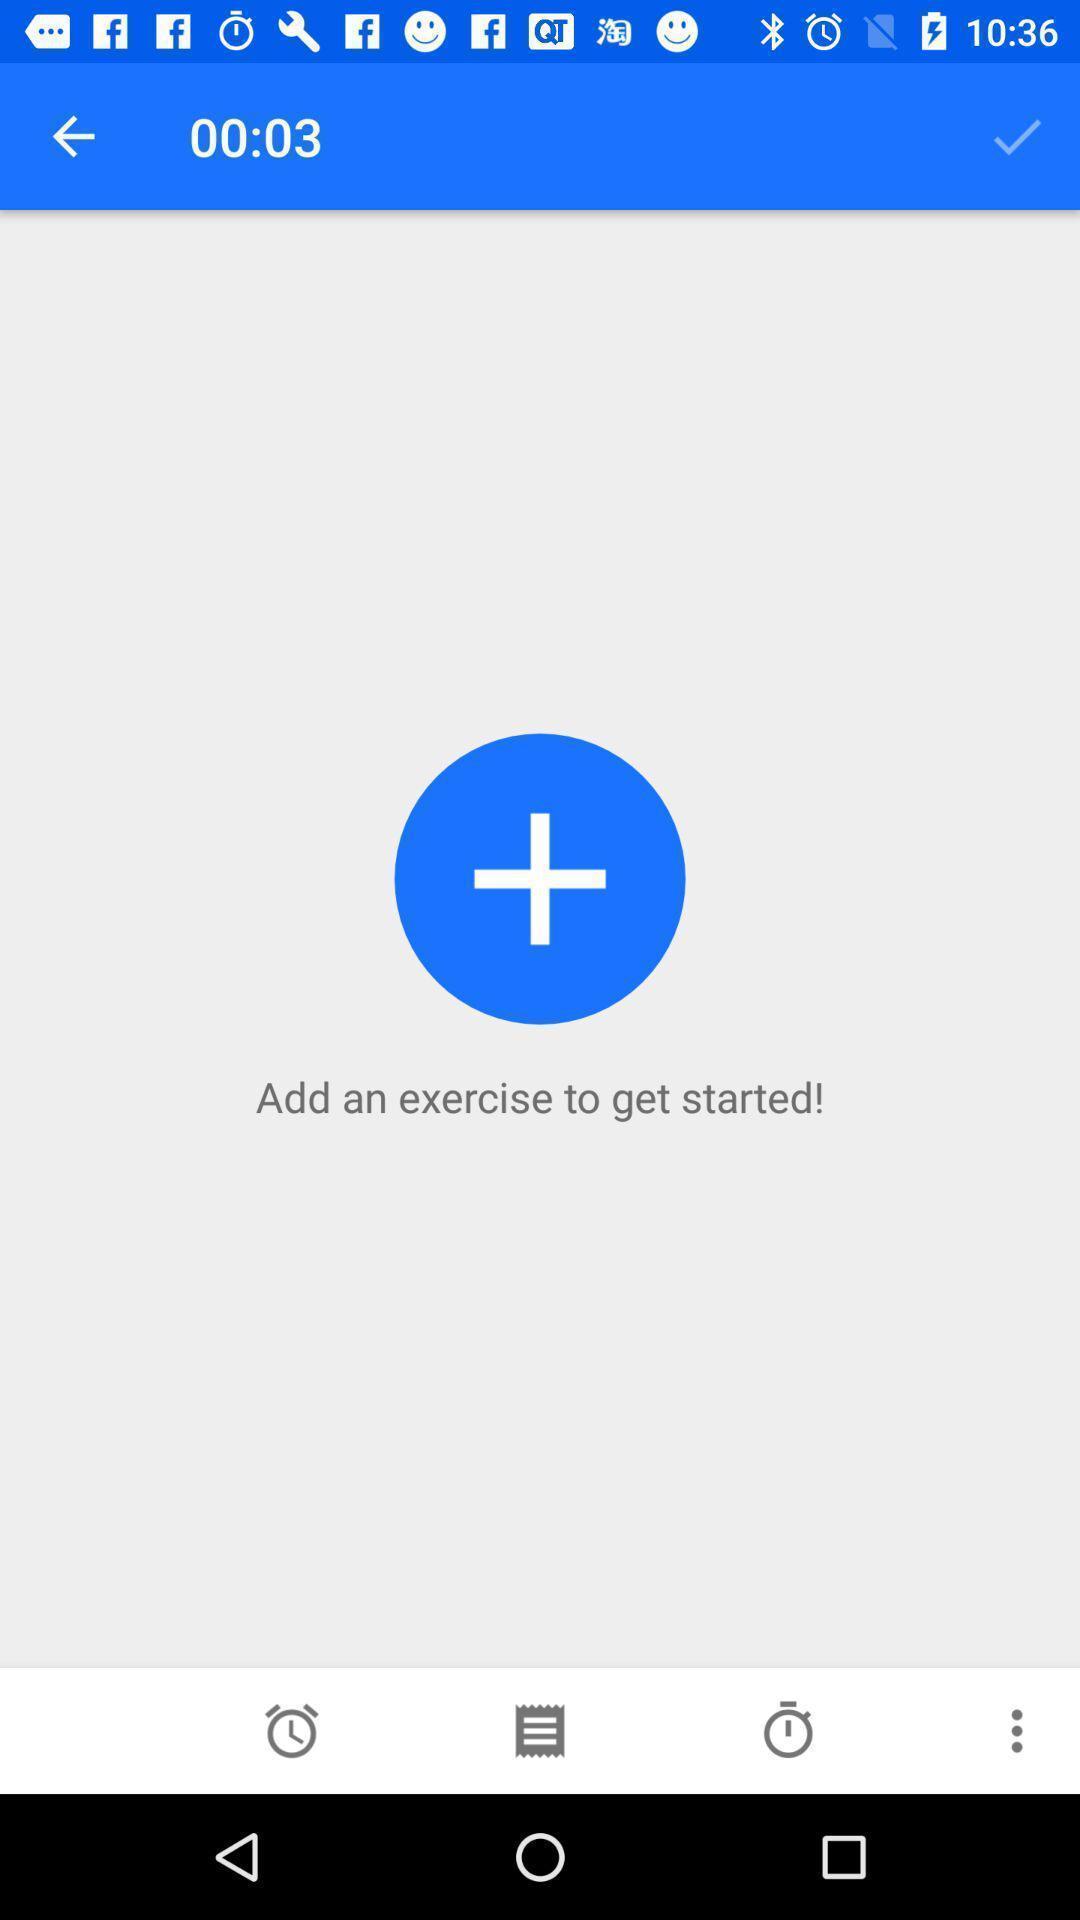What details can you identify in this image? Screen showing add an exercise to get started. 